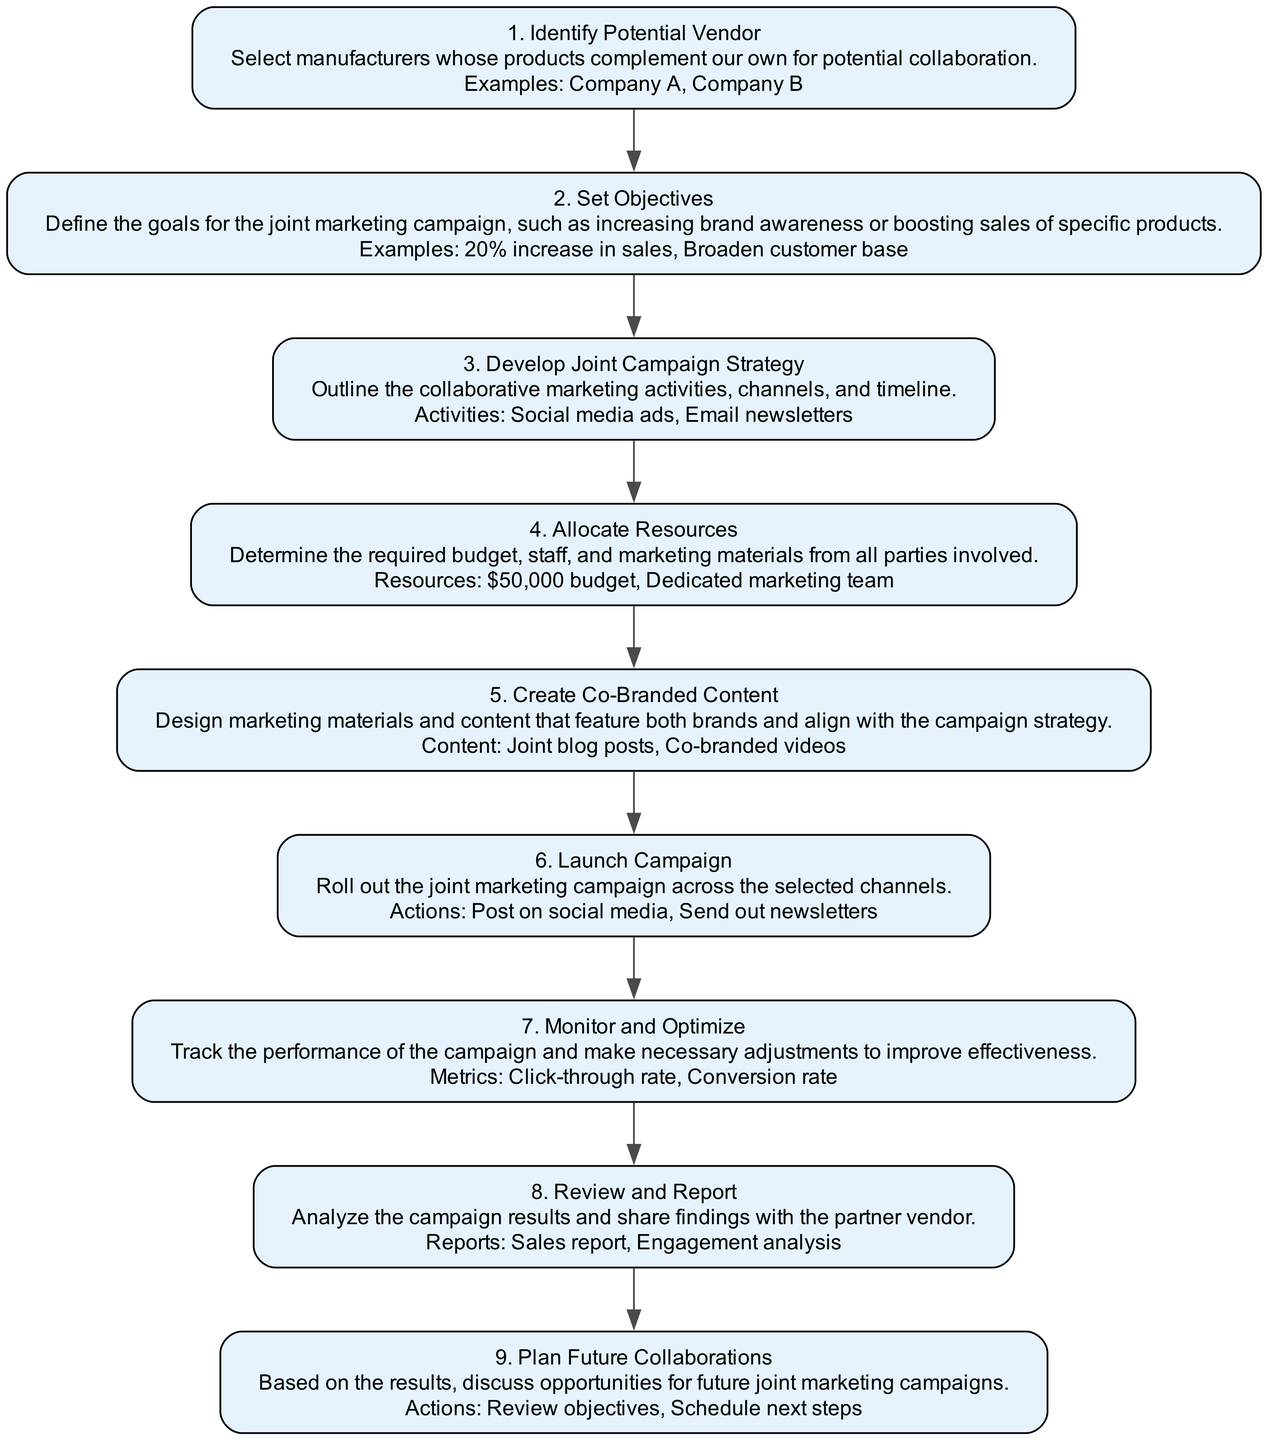What is the first step in the vendor collaboration process? The first step in the flow chart is labeled "1. Identify Potential Vendor," which describes selecting manufacturers whose products complement our own for potential collaboration.
Answer: Identify Potential Vendor What are the resources allocated in the fourth step? In the fourth step, labeled "4. Allocate Resources," the example resources mentioned include a "$50,000 budget" and a "Dedicated marketing team."
Answer: $50,000 budget, Dedicated marketing team Which step involves creating marketing materials? The fifth step, "5. Create Co-Branded Content," focuses on designing marketing materials and content that feature both brands and align with the campaign strategy.
Answer: Create Co-Branded Content How many total steps are there in the diagram? There are a total of nine steps in the flow chart, as each step is numbered sequentially from 1 to 9.
Answer: Nine What is the last step addressed in the collaboration process? The final step in the process is "9. Plan Future Collaborations," which involves discussing opportunities for future campaigns based on previous results.
Answer: Plan Future Collaborations What is the main objective defined in the second step? The second step, "2. Set Objectives," suggests defining goals for the joint marketing campaign, such as increasing sales by 20% or broadening the customer base.
Answer: 20% increase in sales, Broaden customer base Which two examples of marketing activities are outlined in the third step? In "3. Develop Joint Campaign Strategy," the example activities mentioned include "Social media ads" and "Email newsletters."
Answer: Social media ads, Email newsletters What metrics are used to monitor campaign performance? In the seventh step, "7. Monitor and Optimize," the example metrics to track campaign performance include "Click-through rate" and "Conversion rate."
Answer: Click-through rate, Conversion rate 